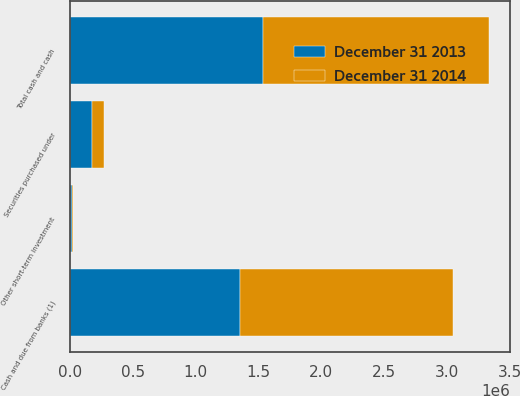<chart> <loc_0><loc_0><loc_500><loc_500><stacked_bar_chart><ecel><fcel>Cash and due from banks (1)<fcel>Securities purchased under<fcel>Other short-term investment<fcel>Total cash and cash<nl><fcel>December 31 2014<fcel>1.69433e+06<fcel>95611<fcel>6122<fcel>1.79606e+06<nl><fcel>December 31 2013<fcel>1.34969e+06<fcel>172989<fcel>16102<fcel>1.53878e+06<nl></chart> 